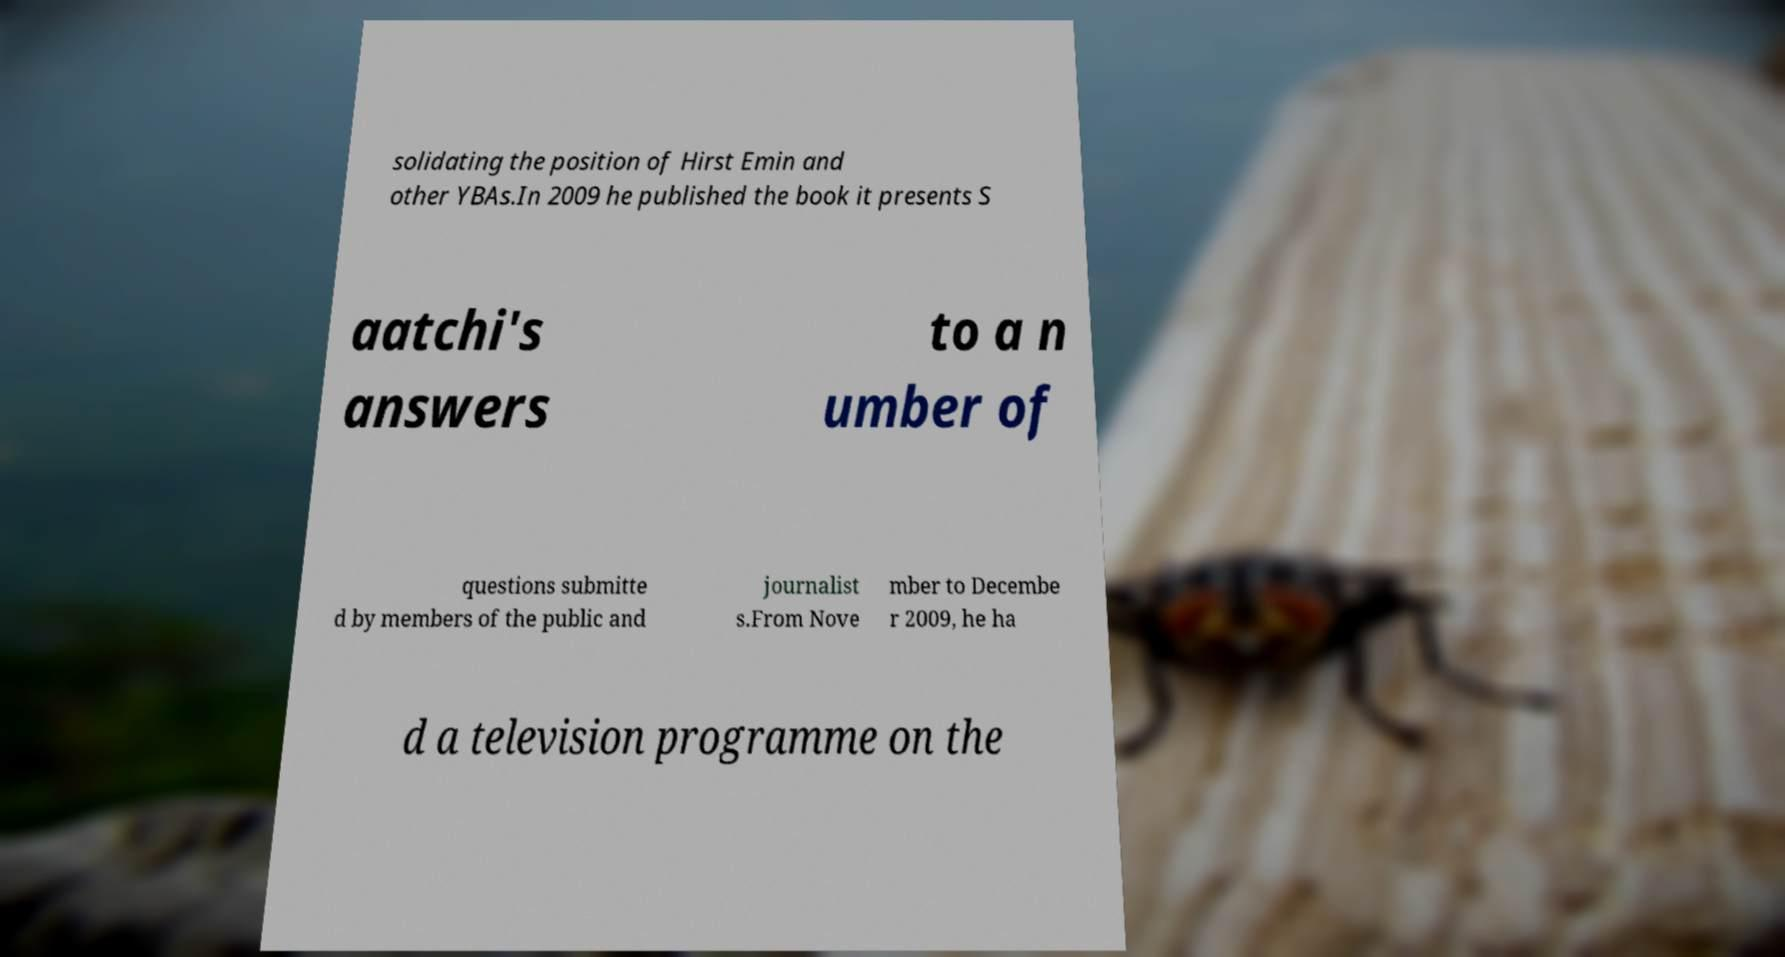I need the written content from this picture converted into text. Can you do that? solidating the position of Hirst Emin and other YBAs.In 2009 he published the book it presents S aatchi's answers to a n umber of questions submitte d by members of the public and journalist s.From Nove mber to Decembe r 2009, he ha d a television programme on the 